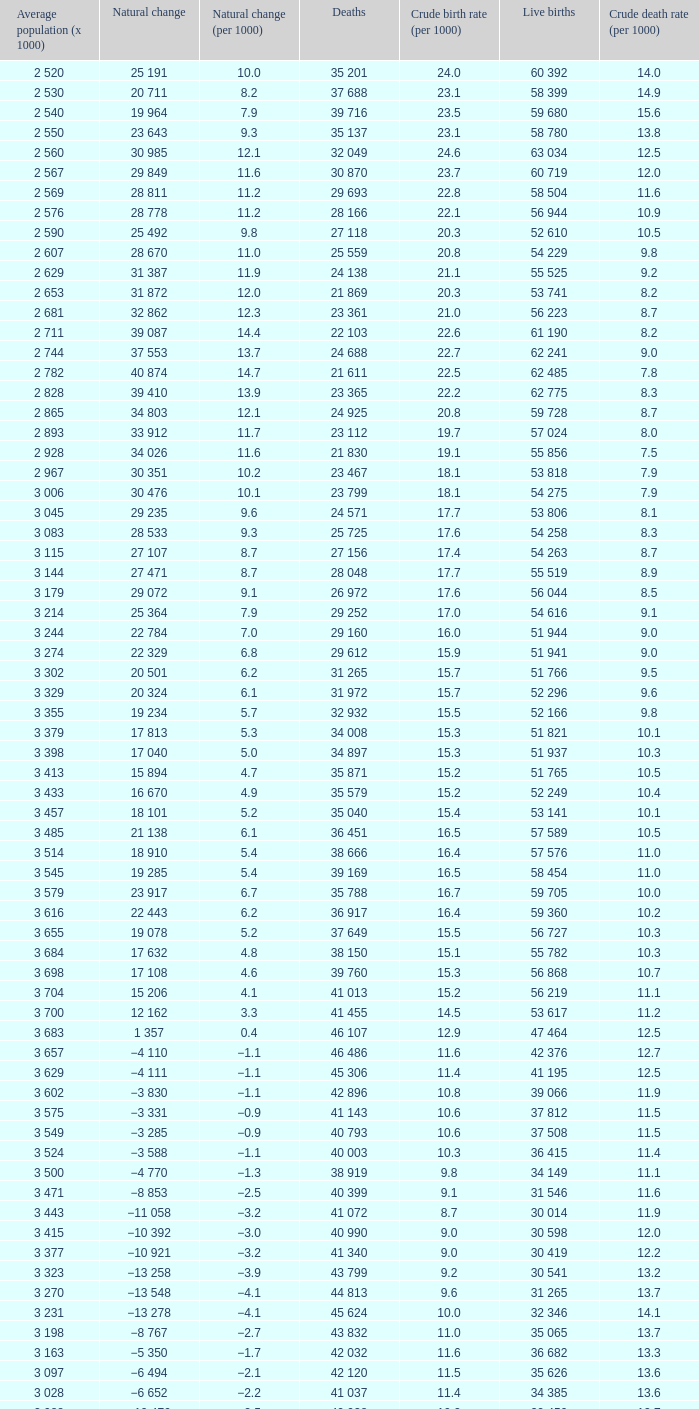Which Live births have a Natural change (per 1000) of 12.0? 53 741. 